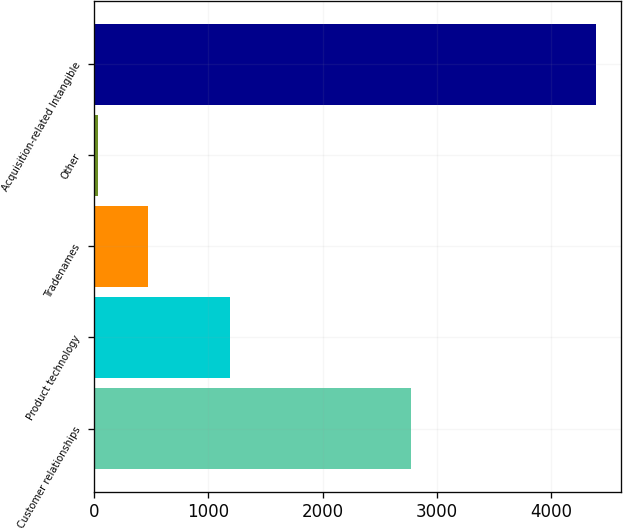<chart> <loc_0><loc_0><loc_500><loc_500><bar_chart><fcel>Customer relationships<fcel>Product technology<fcel>Tradenames<fcel>Other<fcel>Acquisition-related Intangible<nl><fcel>2771.2<fcel>1187<fcel>469.96<fcel>34.6<fcel>4388.2<nl></chart> 